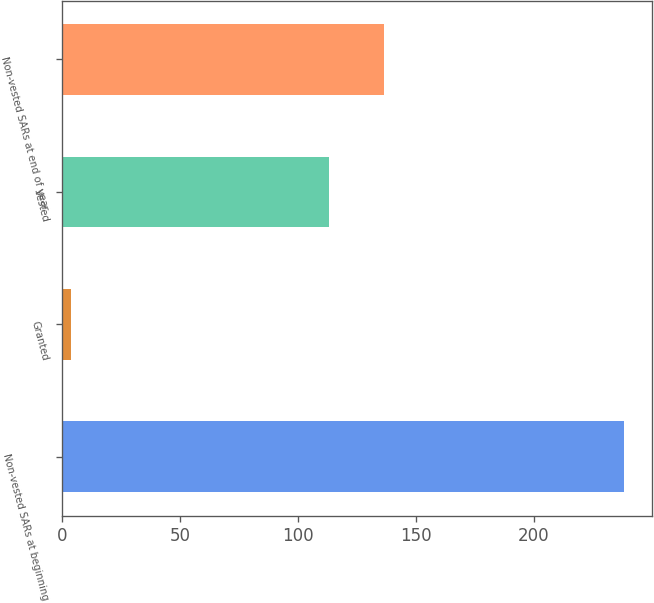Convert chart to OTSL. <chart><loc_0><loc_0><loc_500><loc_500><bar_chart><fcel>Non-vested SARs at beginning<fcel>Granted<fcel>Vested<fcel>Non-vested SARs at end of year<nl><fcel>238<fcel>4<fcel>113<fcel>136.4<nl></chart> 